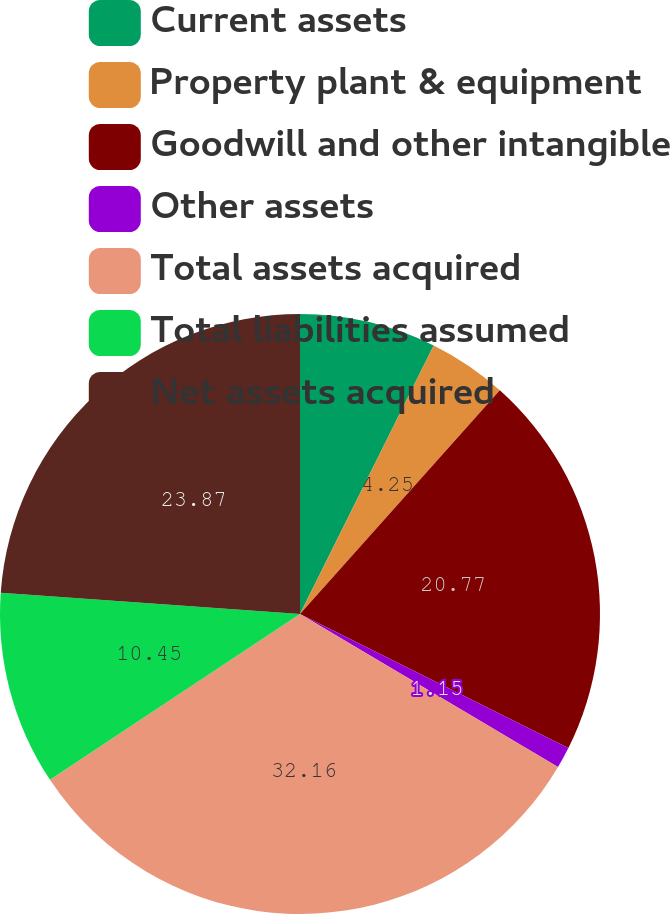<chart> <loc_0><loc_0><loc_500><loc_500><pie_chart><fcel>Current assets<fcel>Property plant & equipment<fcel>Goodwill and other intangible<fcel>Other assets<fcel>Total assets acquired<fcel>Total liabilities assumed<fcel>Net assets acquired<nl><fcel>7.35%<fcel>4.25%<fcel>20.77%<fcel>1.15%<fcel>32.15%<fcel>10.45%<fcel>23.87%<nl></chart> 